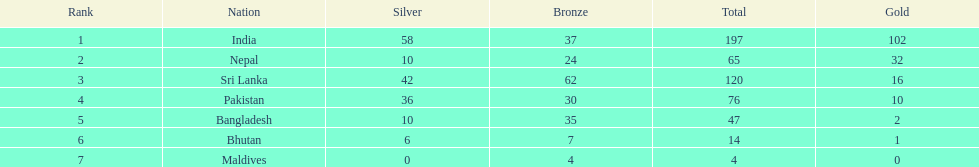Which nation has earned the least amount of gold medals? Maldives. 